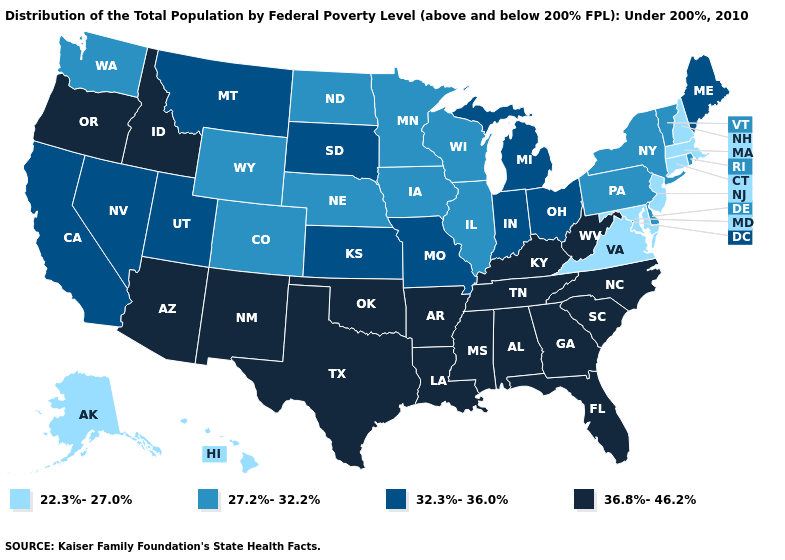Is the legend a continuous bar?
Concise answer only. No. Which states have the highest value in the USA?
Give a very brief answer. Alabama, Arizona, Arkansas, Florida, Georgia, Idaho, Kentucky, Louisiana, Mississippi, New Mexico, North Carolina, Oklahoma, Oregon, South Carolina, Tennessee, Texas, West Virginia. Name the states that have a value in the range 32.3%-36.0%?
Write a very short answer. California, Indiana, Kansas, Maine, Michigan, Missouri, Montana, Nevada, Ohio, South Dakota, Utah. What is the value of South Carolina?
Keep it brief. 36.8%-46.2%. Does Arizona have the highest value in the USA?
Keep it brief. Yes. What is the value of Wisconsin?
Give a very brief answer. 27.2%-32.2%. Does the map have missing data?
Be succinct. No. How many symbols are there in the legend?
Short answer required. 4. Does Kansas have the highest value in the MidWest?
Answer briefly. Yes. What is the value of Massachusetts?
Write a very short answer. 22.3%-27.0%. What is the lowest value in the USA?
Keep it brief. 22.3%-27.0%. What is the lowest value in states that border Texas?
Write a very short answer. 36.8%-46.2%. Name the states that have a value in the range 32.3%-36.0%?
Keep it brief. California, Indiana, Kansas, Maine, Michigan, Missouri, Montana, Nevada, Ohio, South Dakota, Utah. Does Alabama have the same value as Oklahoma?
Write a very short answer. Yes. 